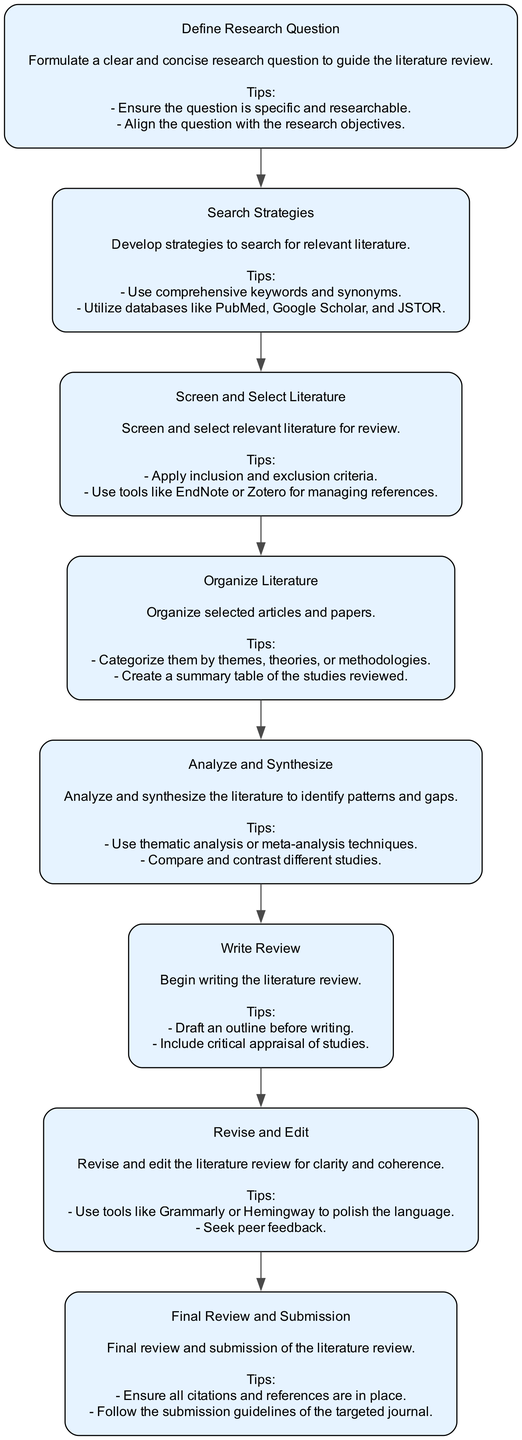What is the first node in the workflow? The first node in the diagram is labeled "Define Research Question." It serves as the starting point of the literature review workflow.
Answer: Define Research Question How many nodes are in the diagram? The diagram contains eight nodes, each representing a key milestone in the literature review process.
Answer: Eight What follows "Screen and Select Literature"? The node that follows "Screen and Select Literature" is "Organize Literature," indicating the next step in the workflow.
Answer: Organize Literature Which node includes tips about using databases like PubMed? The node "Search Strategies" contains tips, specifically mentioning the use of databases like PubMed, Google Scholar, and JSTOR.
Answer: Search Strategies What is the main purpose of the "Analyze and Synthesize" node? The main purpose of the "Analyze and Synthesize" node is to analyze and synthesize the literature to identify patterns and gaps in the research.
Answer: To identify patterns and gaps Which node in the workflow is focused on writing the review? The node focused on writing the review is "Write Review," which emphasizes the drafting process of the literature review.
Answer: Write Review What milestone comes before "Revise and Edit"? The milestone that comes before "Revise and Edit" is "Write Review," indicating that writing must be completed prior to revision.
Answer: Write Review How does the workflow proceed after the "Final Review and Submission" node? The workflow does not proceed after the "Final Review and Submission" node, as it represents the last step in the literature review process.
Answer: No further steps 